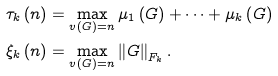Convert formula to latex. <formula><loc_0><loc_0><loc_500><loc_500>\tau _ { k } \left ( n \right ) & = \max _ { v \left ( G \right ) = n } \mu _ { 1 } \left ( G \right ) + \cdots + \mu _ { k } \left ( G \right ) \\ \xi _ { k } \left ( n \right ) & = \max _ { v \left ( G \right ) = n } \left \| G \right \| _ { F _ { k } } .</formula> 